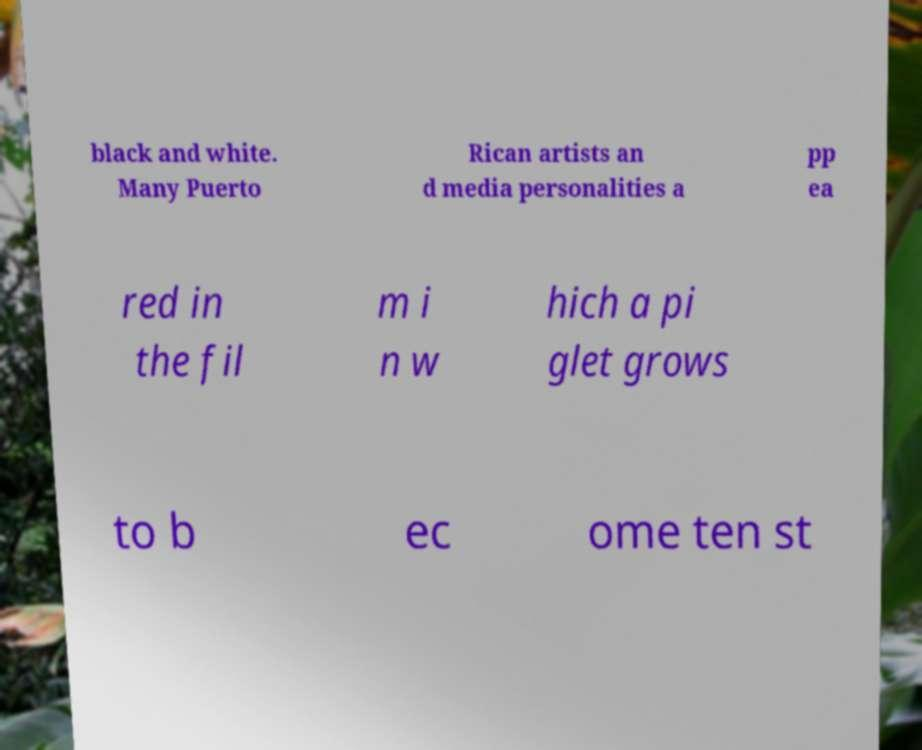Could you assist in decoding the text presented in this image and type it out clearly? black and white. Many Puerto Rican artists an d media personalities a pp ea red in the fil m i n w hich a pi glet grows to b ec ome ten st 